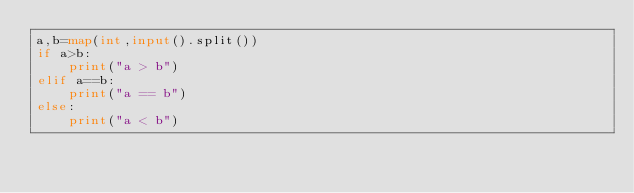Convert code to text. <code><loc_0><loc_0><loc_500><loc_500><_Python_>a,b=map(int,input().split())
if a>b:
    print("a > b")
elif a==b:
    print("a == b")
else:
    print("a < b")
</code> 